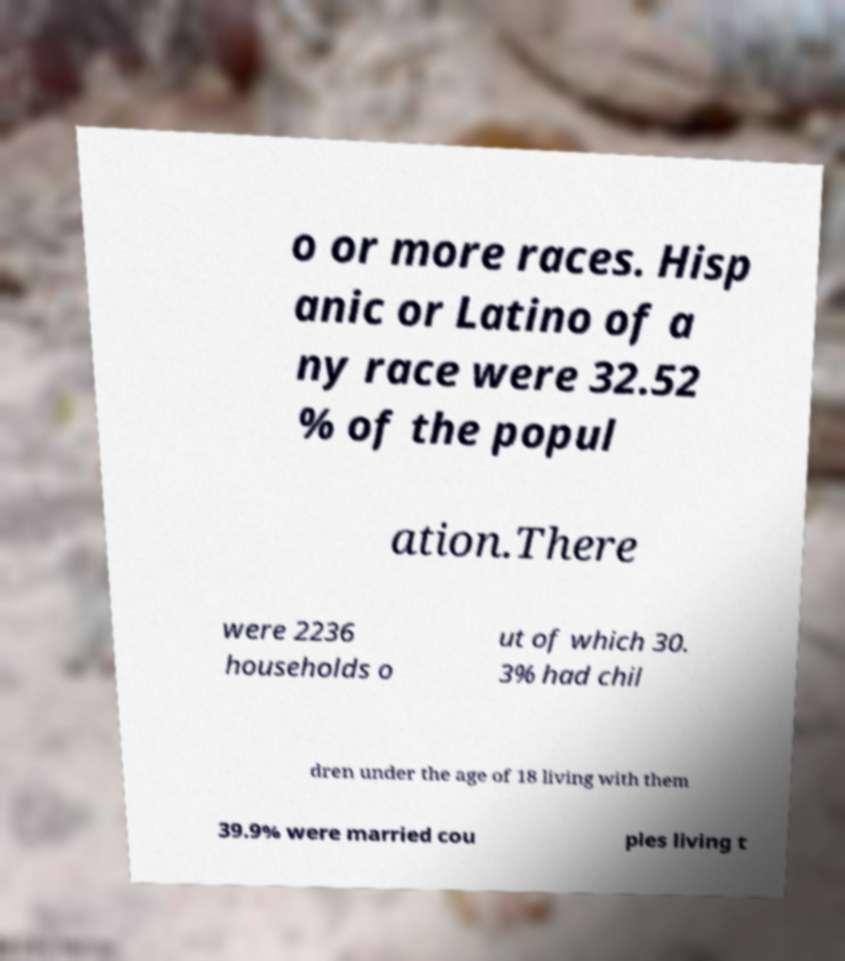For documentation purposes, I need the text within this image transcribed. Could you provide that? o or more races. Hisp anic or Latino of a ny race were 32.52 % of the popul ation.There were 2236 households o ut of which 30. 3% had chil dren under the age of 18 living with them 39.9% were married cou ples living t 